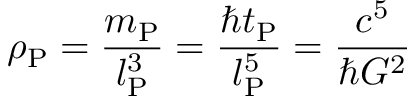<formula> <loc_0><loc_0><loc_500><loc_500>\rho _ { P } = { \frac { m _ { P } } { l _ { P } ^ { 3 } } } = { \frac { \hbar { t } _ { P } } { l _ { P } ^ { 5 } } } = { \frac { c ^ { 5 } } { \hbar { G } ^ { 2 } } }</formula> 